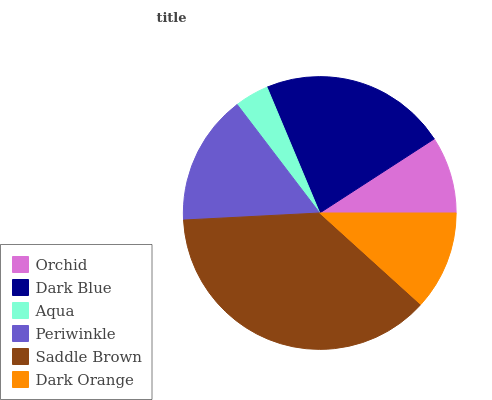Is Aqua the minimum?
Answer yes or no. Yes. Is Saddle Brown the maximum?
Answer yes or no. Yes. Is Dark Blue the minimum?
Answer yes or no. No. Is Dark Blue the maximum?
Answer yes or no. No. Is Dark Blue greater than Orchid?
Answer yes or no. Yes. Is Orchid less than Dark Blue?
Answer yes or no. Yes. Is Orchid greater than Dark Blue?
Answer yes or no. No. Is Dark Blue less than Orchid?
Answer yes or no. No. Is Periwinkle the high median?
Answer yes or no. Yes. Is Dark Orange the low median?
Answer yes or no. Yes. Is Saddle Brown the high median?
Answer yes or no. No. Is Saddle Brown the low median?
Answer yes or no. No. 